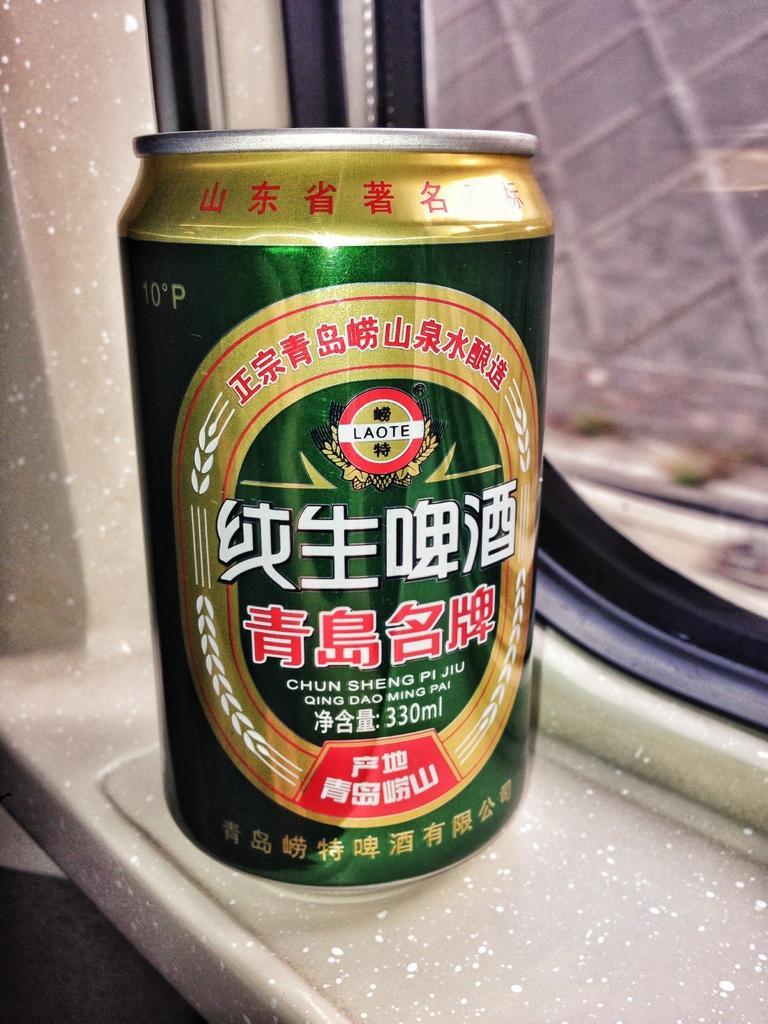Could you give a brief overview of what you see in this image? In the picture we can see a wine tin which is green in color with some label to it which is placed near the window with a glass. 